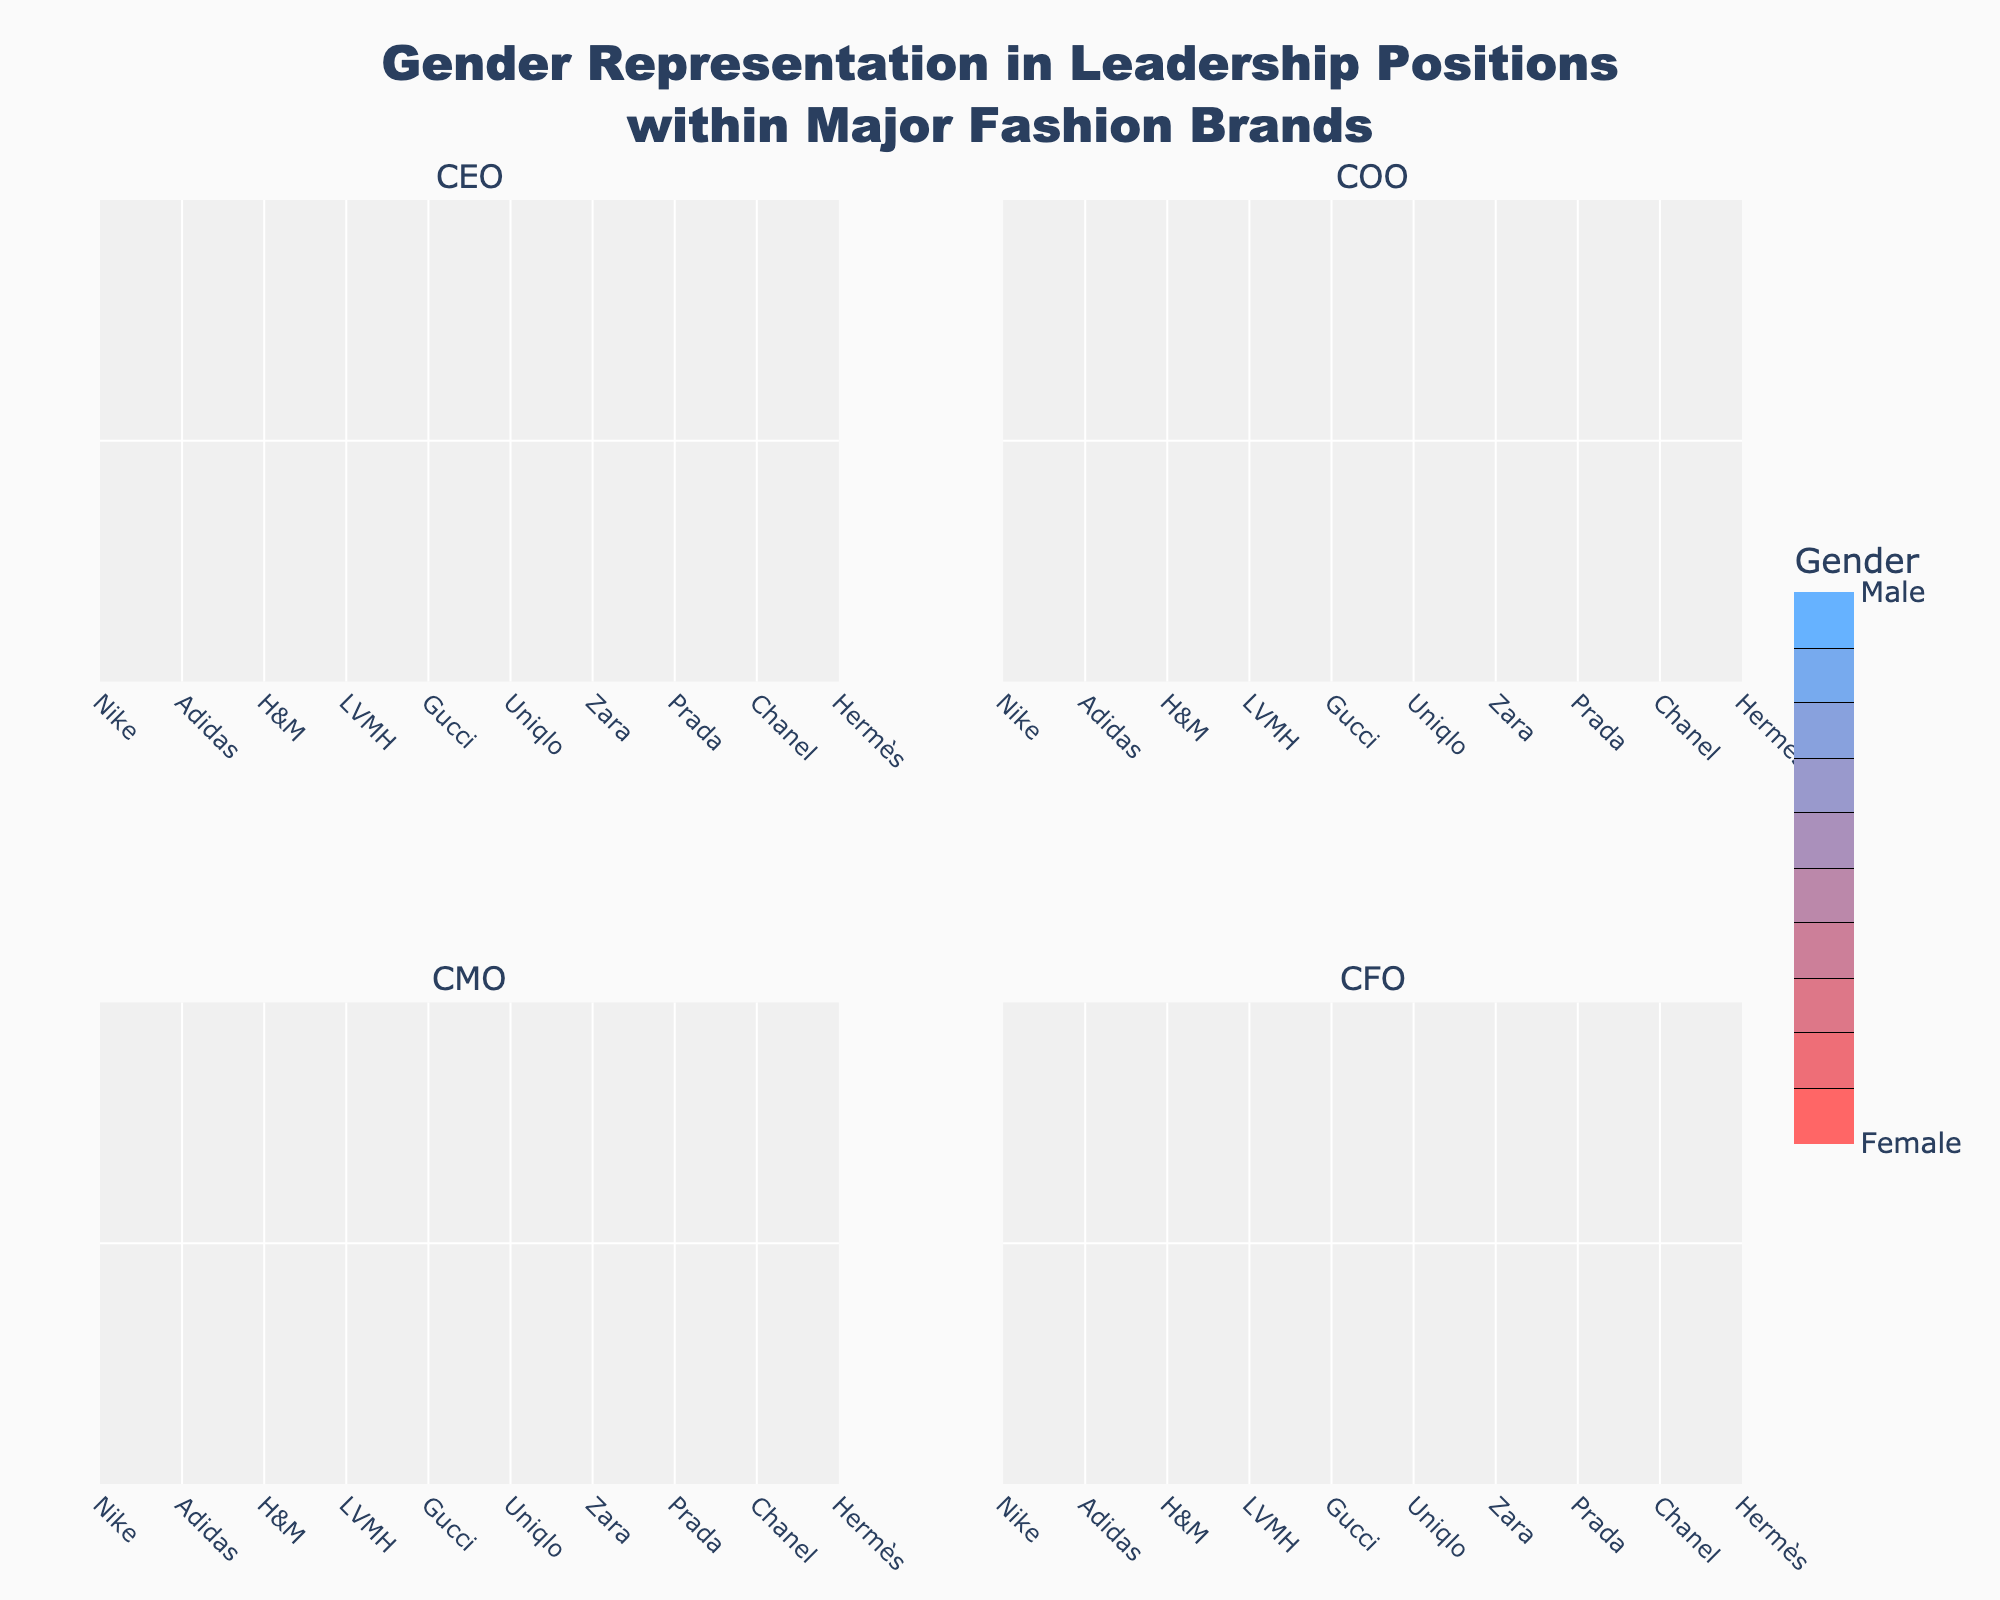What is the title of the plot? The title of the plot is displayed at the top center of the figure. It reads 'Gender Representation in Leadership Positions within Major Fashion Brands'.
Answer: Gender Representation in Leadership Positions within Major Fashion Brands How many subplots are present in the figure? The figure has a 2x2 grid layout, with each grid corresponding to a leadership position (CEO, COO, CMO, CFO). This makes a total of 4 subplots.
Answer: 4 Which brands have female CEOs? By observing the subplot titled 'CEO' and looking for contour plots marked with the color corresponding to females, we can see that H&M, Gucci, Zara, and Chanel have female CEOs.
Answer: H&M, Gucci, Zara, Chanel Which leadership position has the highest number of female leaders among the brands? To find this, we need to count the number of female representations in each subplot. The 'CFO' position has 6 female leaders, which is the highest compared to other leadership positions.
Answer: CFO How many brands have male COOs? We look at the subplot titled 'COO' and count the grid cells colored for male representation. We find that 5 brands have male COOs.
Answer: 5 How would you describe the gender distribution for the CMO position among the brands? By examining the subplot titled 'CMO', we observe that 6 brands have female CMOs and 4 brands have male CMOs, indicating a slightly higher representation of females in the CMO position.
Answer: 6 females, 4 males Which brand has a female representation in all four leadership positions? To answer this, we need to check each subplot for consistent female representation within a single brand. Zara is the brand with females in all four positions (CEO, COO, CMO, CFO).
Answer: Zara Compare the gender distribution between CEO and CFO positions. Which one shows greater gender diversity? CEO position has 4 females and 6 males, while CFO has 6 females and 4 males. Both positions have a mix of genders, but CFO has a more balanced distribution, showing greater gender diversity.
Answer: CFO What is the total number of leadership positions held by women across all brands? Each subplot represents one type of leadership position; summing all females across CEO, COO, CMO, and CFO positions: (4 + 5 + 6 + 6) results in a total of 21 female leadership positions.
Answer: 21 How does the gender representation in COO positions compare to that of CMO positions? COO has 5 females and 5 males, while CMO has 6 females and 4 males. Thus, CMO has a slightly higher representation of females compared to COO.
Answer: CMO has more females 